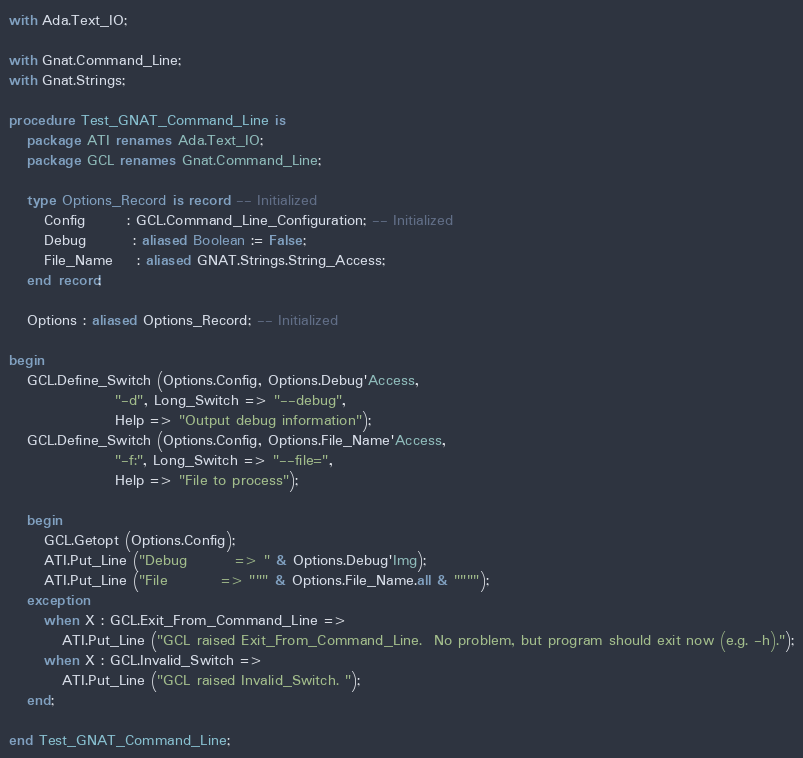Convert code to text. <code><loc_0><loc_0><loc_500><loc_500><_Ada_>with Ada.Text_IO;

with Gnat.Command_Line;
with Gnat.Strings;

procedure Test_GNAT_Command_Line is
   package ATI renames Ada.Text_IO;
   package GCL renames Gnat.Command_Line;

   type Options_Record is record -- Initialized
      Config       : GCL.Command_Line_Configuration; -- Initialized
      Debug        : aliased Boolean := False;
      File_Name    : aliased GNAT.Strings.String_Access;
   end record;

   Options : aliased Options_Record; -- Initialized

begin
   GCL.Define_Switch (Options.Config, Options.Debug'Access,
                  "-d", Long_Switch => "--debug",
                  Help => "Output debug information");
   GCL.Define_Switch (Options.Config, Options.File_Name'Access,
                  "-f:", Long_Switch => "--file=",
                  Help => "File to process");

   begin
      GCL.Getopt (Options.Config);
      ATI.Put_Line ("Debug        => " & Options.Debug'Img);
      ATI.Put_Line ("File         => """ & Options.File_Name.all & """");
   exception
      when X : GCL.Exit_From_Command_Line =>
         ATI.Put_Line ("GCL raised Exit_From_Command_Line.  No problem, but program should exit now (e.g. -h).");
      when X : GCL.Invalid_Switch =>
         ATI.Put_Line ("GCL raised Invalid_Switch. ");
   end;

end Test_GNAT_Command_Line;
</code> 